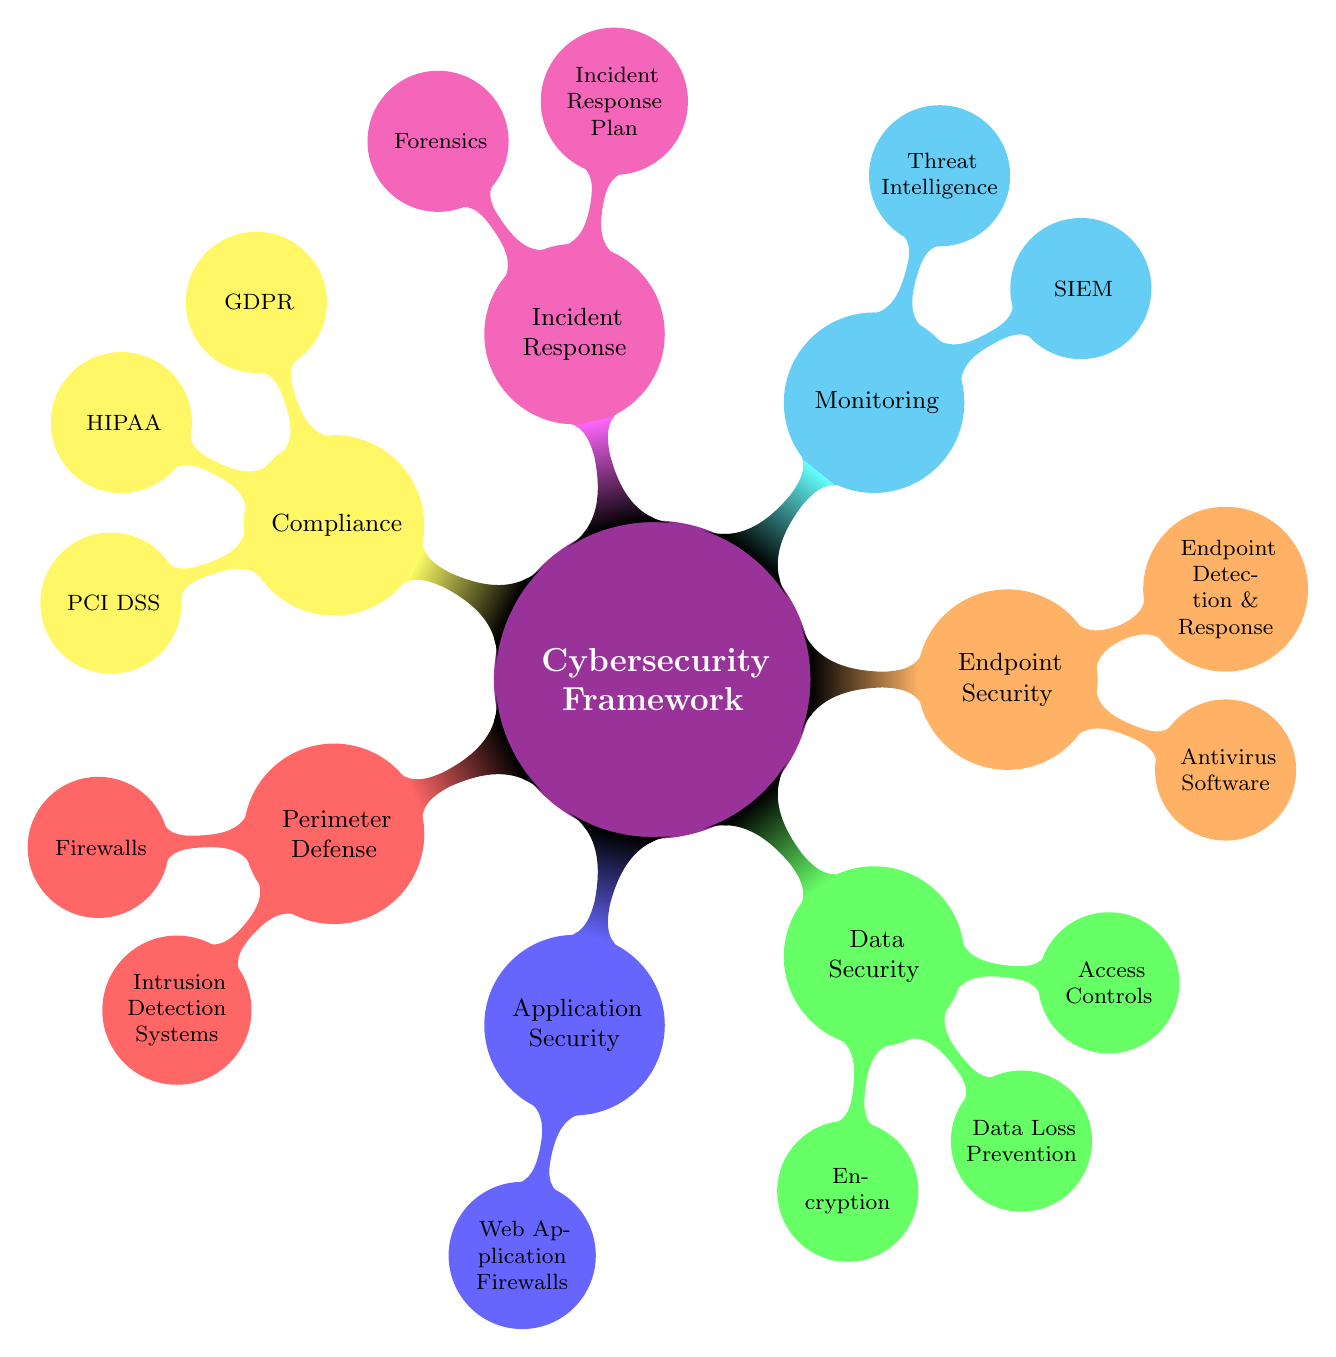What is the main focus of the diagram? The diagram focuses on outlining a cybersecurity framework, which includes various components of a company's cybersecurity strategy.
Answer: Cybersecurity Framework How many layers of protection are depicted in the diagram? The diagram displays six distinct layers of protection within the cybersecurity framework, each represented by a unique color.
Answer: 6 What color represents Monitoring in the diagram? Monitoring is represented in cyan color in the diagram, as shown by the corresponding node.
Answer: Cyan Which two compliance requirements are included in the diagram? The diagram specifically includes GDPR and HIPAA as compliance requirements in its compliance layer.
Answer: GDPR, HIPAA What is the specific node under Endpoint Security? Under Endpoint Security, the diagram includes two specific nodes: Antivirus Software and Endpoint Detection & Response.
Answer: Antivirus Software, Endpoint Detection & Response Which layer includes Encryption as a key component? Encryption is a key component under the Data Security layer, which is depicted in green color in the diagram.
Answer: Data Security What are the child nodes under Incident Response? The child nodes under Incident Response in the diagram are Incident Response Plan and Forensics.
Answer: Incident Response Plan, Forensics How many monitoring techniques are shown in the Monitoring layer? The Monitoring layer contains two techniques, which are SIEM and Threat Intelligence, as depicted in the diagram.
Answer: 2 What is the only component listed under Application Security? The only component listed under Application Security in the diagram is the Web Application Firewall.
Answer: Web Application Firewall 